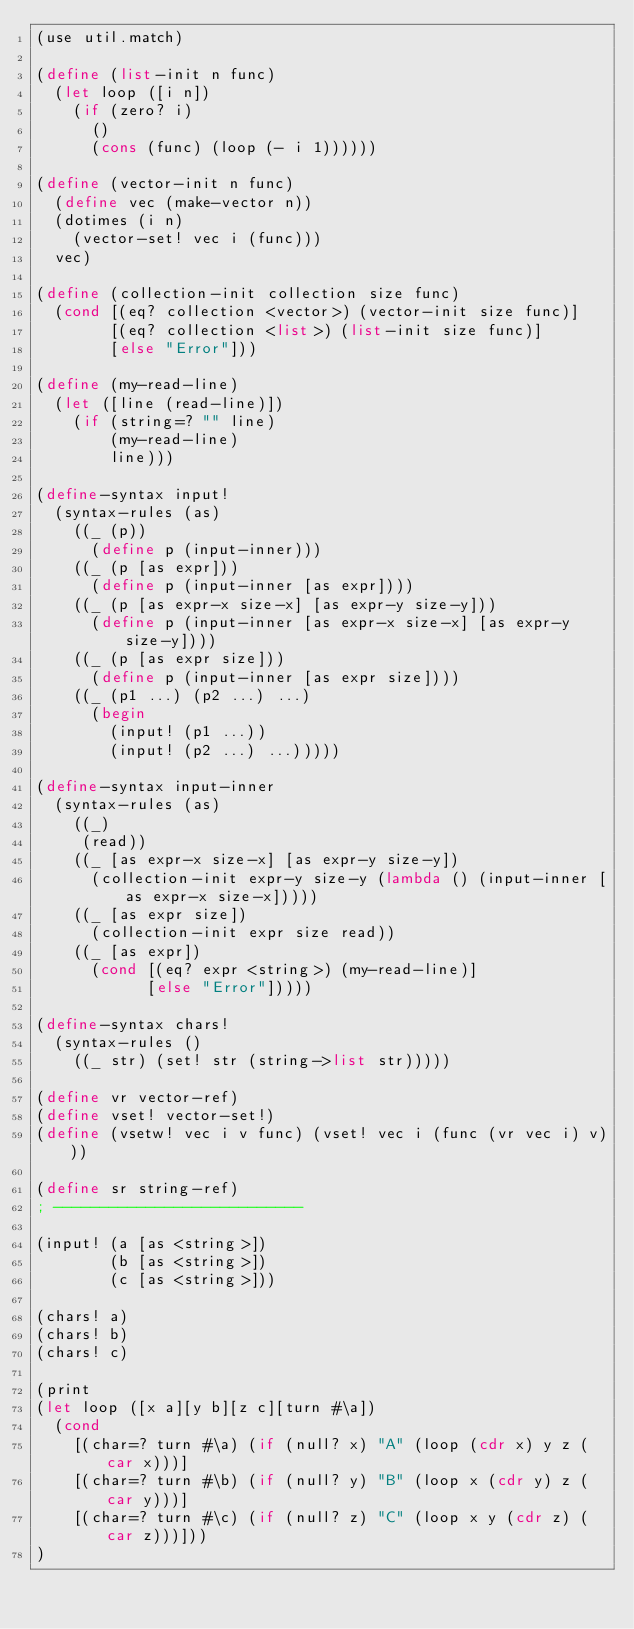<code> <loc_0><loc_0><loc_500><loc_500><_Scheme_>(use util.match)

(define (list-init n func)
  (let loop ([i n])
    (if (zero? i)
      ()
      (cons (func) (loop (- i 1))))))

(define (vector-init n func)
  (define vec (make-vector n))
  (dotimes (i n)
    (vector-set! vec i (func)))
  vec)

(define (collection-init collection size func)
  (cond [(eq? collection <vector>) (vector-init size func)]
        [(eq? collection <list>) (list-init size func)]
        [else "Error"]))

(define (my-read-line)
  (let ([line (read-line)])
    (if (string=? "" line)
        (my-read-line)
        line)))

(define-syntax input!
  (syntax-rules (as)
    ((_ (p))
      (define p (input-inner)))
    ((_ (p [as expr]))
      (define p (input-inner [as expr])))
    ((_ (p [as expr-x size-x] [as expr-y size-y]))
      (define p (input-inner [as expr-x size-x] [as expr-y size-y])))
    ((_ (p [as expr size]))
      (define p (input-inner [as expr size])))
    ((_ (p1 ...) (p2 ...) ...)
      (begin 
        (input! (p1 ...))
        (input! (p2 ...) ...)))))

(define-syntax input-inner
  (syntax-rules (as)
    ((_)
     (read))
    ((_ [as expr-x size-x] [as expr-y size-y])
      (collection-init expr-y size-y (lambda () (input-inner [as expr-x size-x]))))
    ((_ [as expr size])
      (collection-init expr size read))
    ((_ [as expr])
      (cond [(eq? expr <string>) (my-read-line)]
            [else "Error"]))))

(define-syntax chars! 
  (syntax-rules ()
    ((_ str) (set! str (string->list str)))))

(define vr vector-ref)
(define vset! vector-set!)
(define (vsetw! vec i v func) (vset! vec i (func (vr vec i) v)))
 
(define sr string-ref)
; ---------------------------

(input! (a [as <string>]) 
        (b [as <string>])
        (c [as <string>]))

(chars! a)
(chars! b)
(chars! c)

(print
(let loop ([x a][y b][z c][turn #\a])
  (cond
    [(char=? turn #\a) (if (null? x) "A" (loop (cdr x) y z (car x)))]
    [(char=? turn #\b) (if (null? y) "B" (loop x (cdr y) z (car y)))]
    [(char=? turn #\c) (if (null? z) "C" (loop x y (cdr z) (car z)))]))
)

</code> 